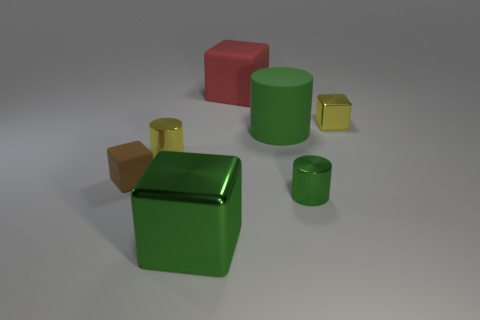Are there an equal number of red blocks to the right of the green rubber object and small cylinders that are to the left of the yellow cube?
Provide a short and direct response. No. There is a small thing that is both on the left side of the green metal cylinder and behind the tiny brown cube; what color is it?
Offer a terse response. Yellow. What material is the tiny cube that is in front of the cube that is right of the large matte cube made of?
Provide a succinct answer. Rubber. Do the green metal cylinder and the brown matte block have the same size?
Provide a succinct answer. Yes. What number of tiny things are either yellow spheres or brown things?
Your response must be concise. 1. How many large red things are left of the large green cube?
Provide a succinct answer. 0. Are there more large green cylinders to the left of the small brown matte cube than green cylinders?
Keep it short and to the point. No. The green object that is the same material as the brown block is what shape?
Offer a very short reply. Cylinder. What is the color of the metallic cube that is to the right of the green thing to the right of the big green cylinder?
Provide a short and direct response. Yellow. Does the red matte object have the same shape as the brown matte thing?
Ensure brevity in your answer.  Yes. 